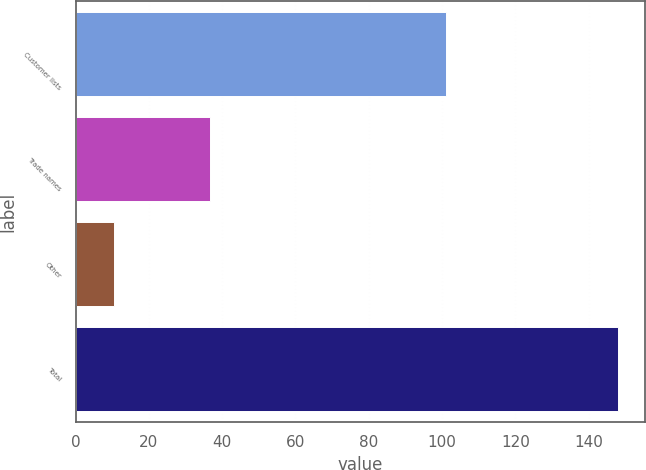Convert chart to OTSL. <chart><loc_0><loc_0><loc_500><loc_500><bar_chart><fcel>Customer lists<fcel>Trade names<fcel>Other<fcel>Total<nl><fcel>101<fcel>36.6<fcel>10.5<fcel>148.1<nl></chart> 